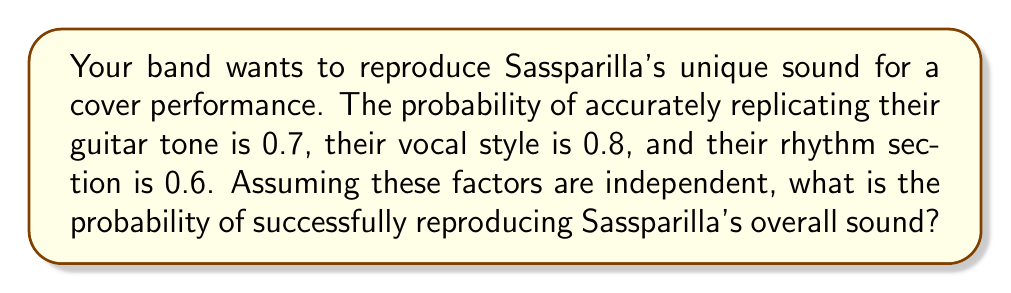Give your solution to this math problem. To solve this problem, we need to use the multiplication rule for independent events. Since we want to successfully reproduce all three aspects of Sassparilla's sound (guitar tone, vocal style, and rhythm section), we need to calculate the probability of all these events occurring together.

Let's define our events:
- G: Successfully replicating the guitar tone (P(G) = 0.7)
- V: Successfully replicating the vocal style (P(V) = 0.8)
- R: Successfully replicating the rhythm section (P(R) = 0.6)

We want to find P(G ∩ V ∩ R), which is the probability of all three events occurring simultaneously.

Since the events are independent, we can multiply their individual probabilities:

$$P(G \cap V \cap R) = P(G) \times P(V) \times P(R)$$

Substituting the given probabilities:

$$P(G \cap V \cap R) = 0.7 \times 0.8 \times 0.6$$

Calculating:

$$P(G \cap V \cap R) = 0.336$$

Therefore, the probability of successfully reproducing Sassparilla's overall sound is 0.336 or 33.6%.
Answer: 0.336 or 33.6% 